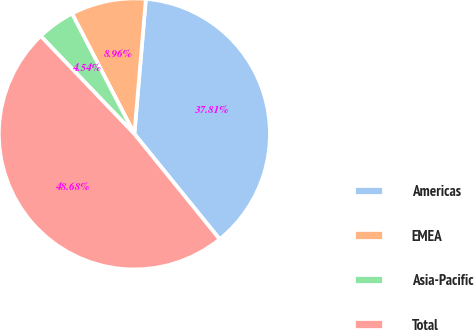Convert chart to OTSL. <chart><loc_0><loc_0><loc_500><loc_500><pie_chart><fcel>Americas<fcel>EMEA<fcel>Asia-Pacific<fcel>Total<nl><fcel>37.81%<fcel>8.96%<fcel>4.54%<fcel>48.68%<nl></chart> 